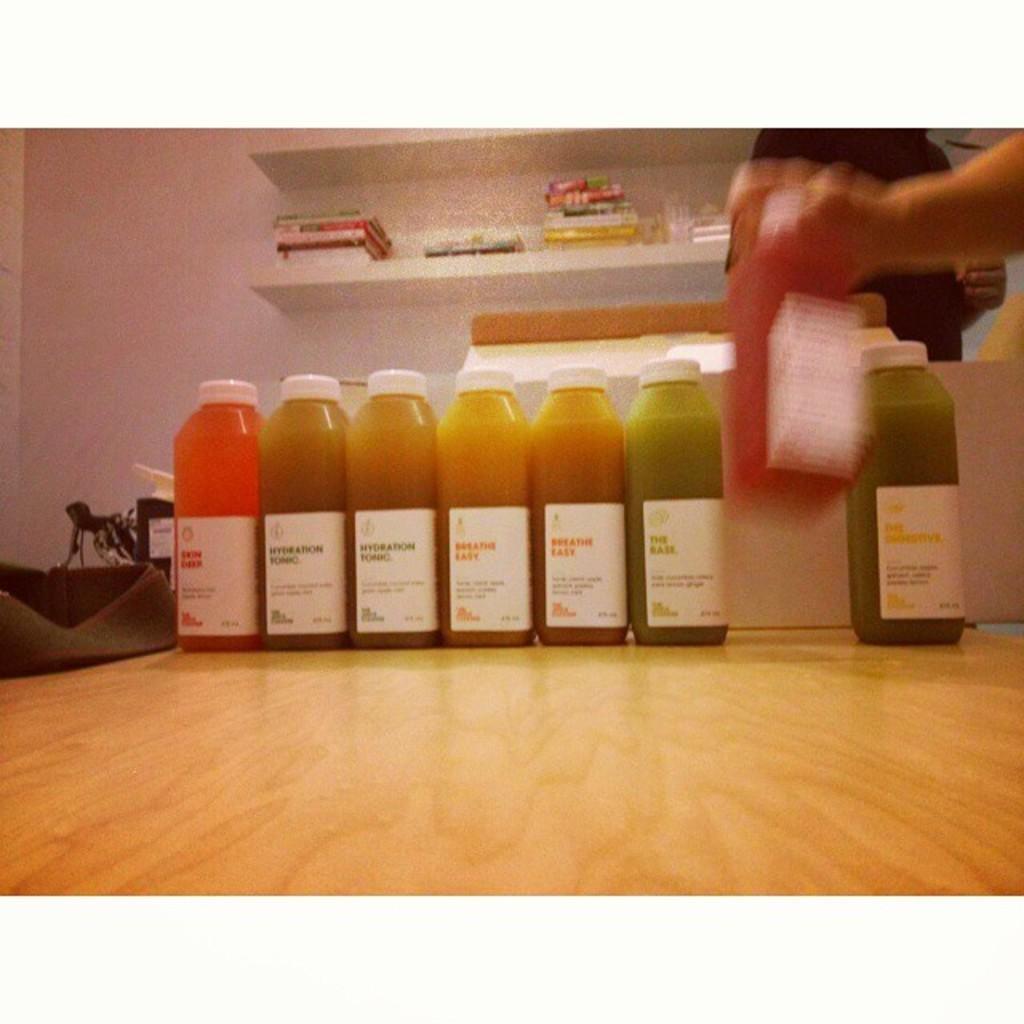Please provide a concise description of this image. This image consists of bottles in which there are juices. They are placed on a table and a person hand is visible on the right side top corner. On the top there are books in bookshelves. 